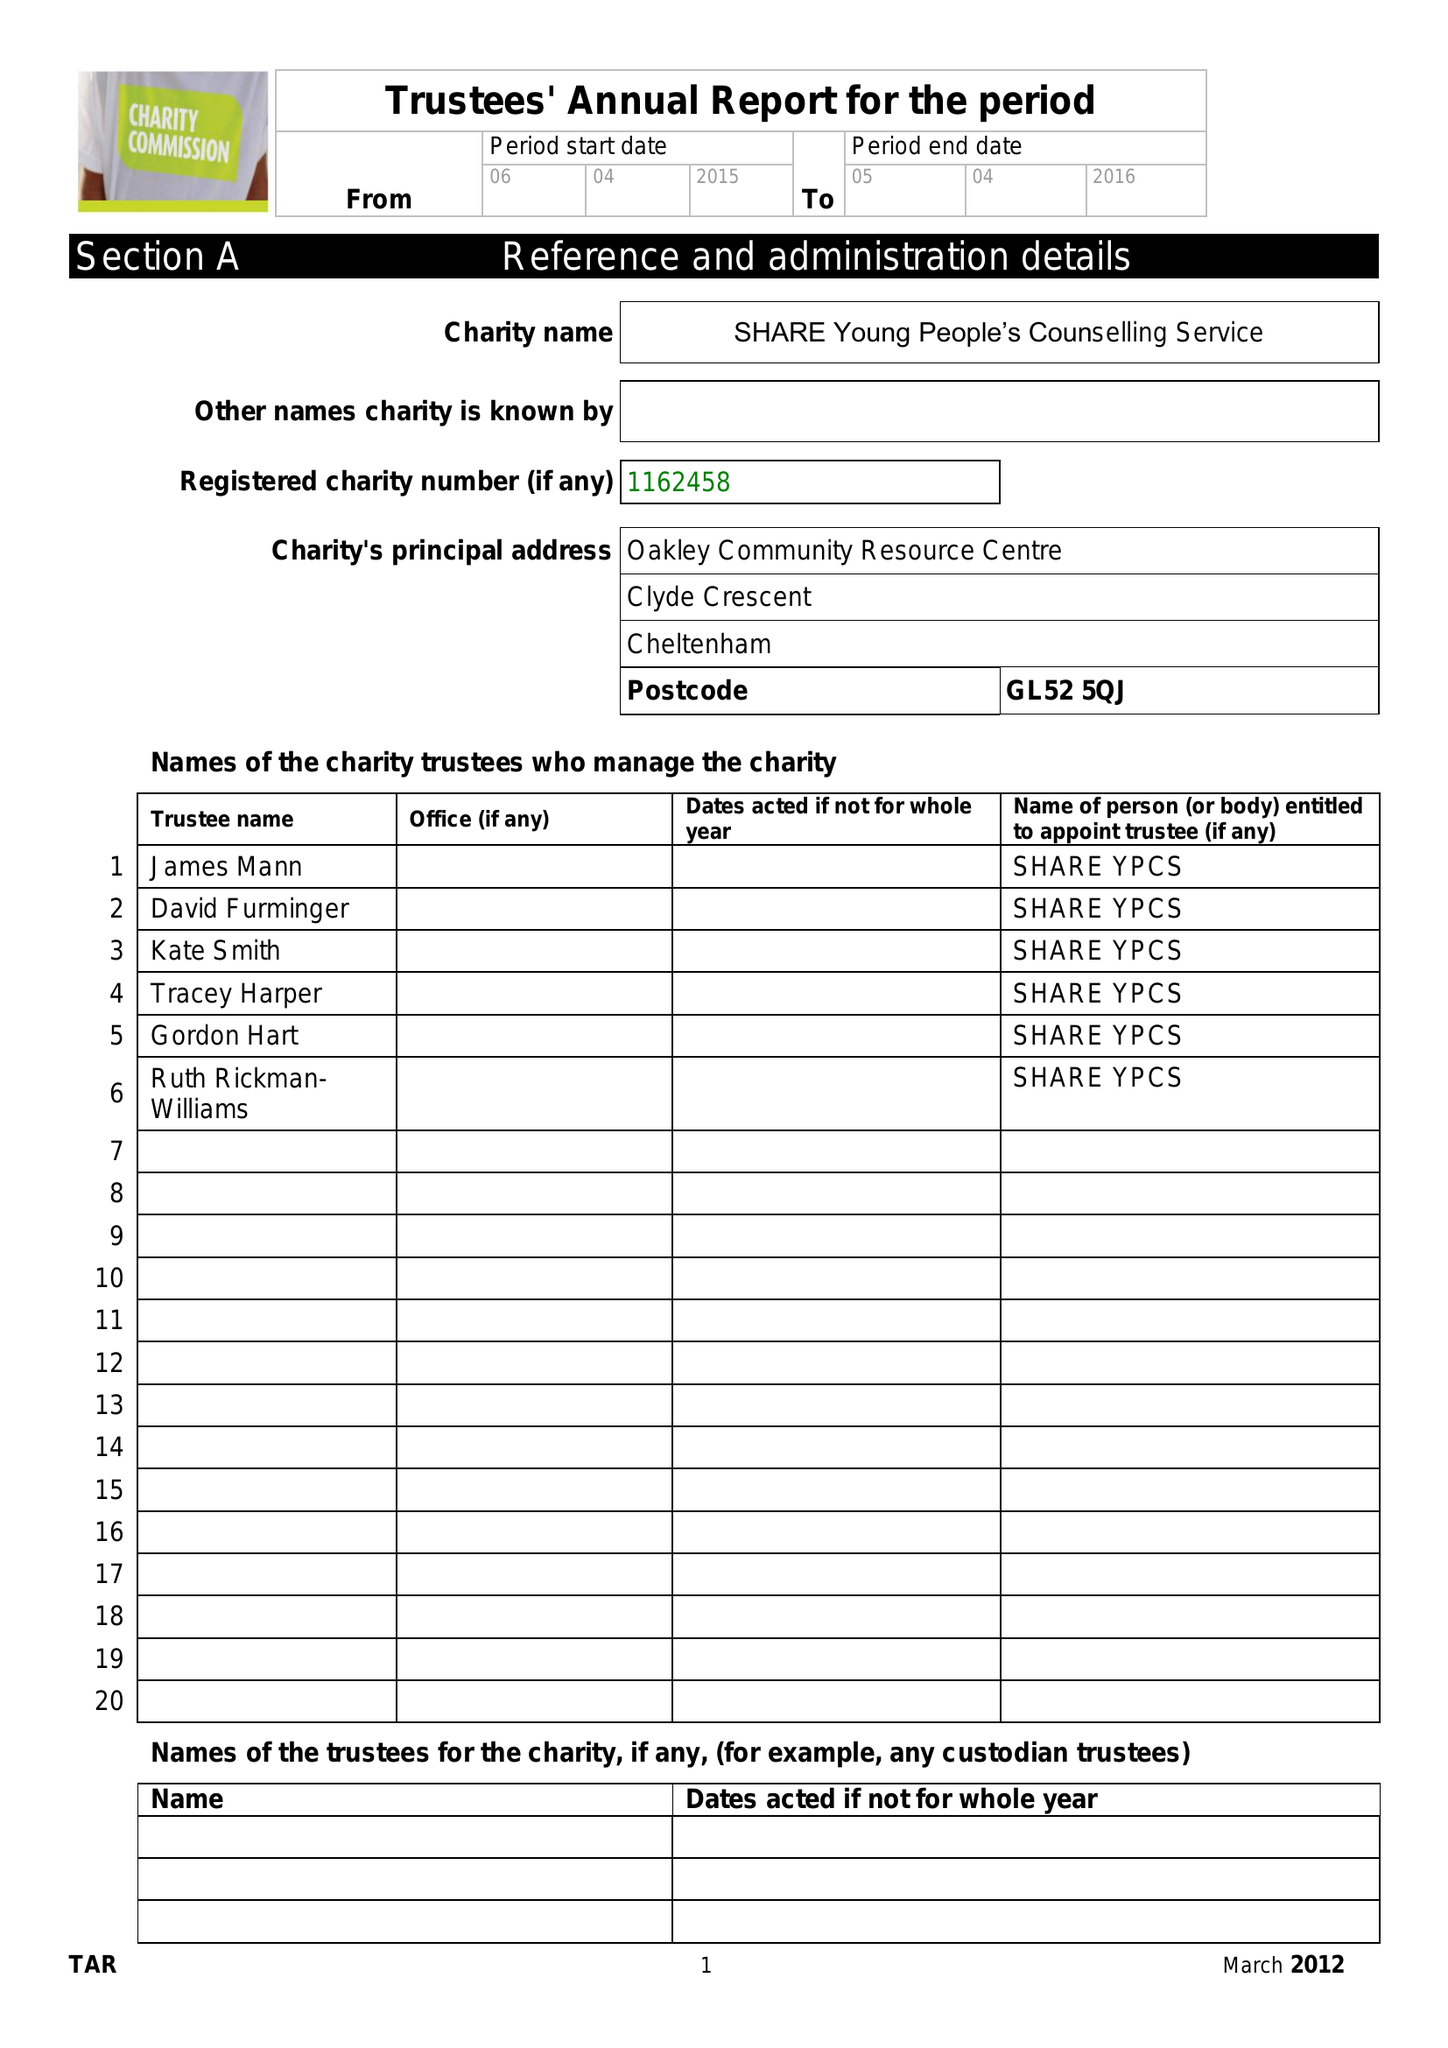What is the value for the address__street_line?
Answer the question using a single word or phrase. 113A CLYDE CRESCENT 